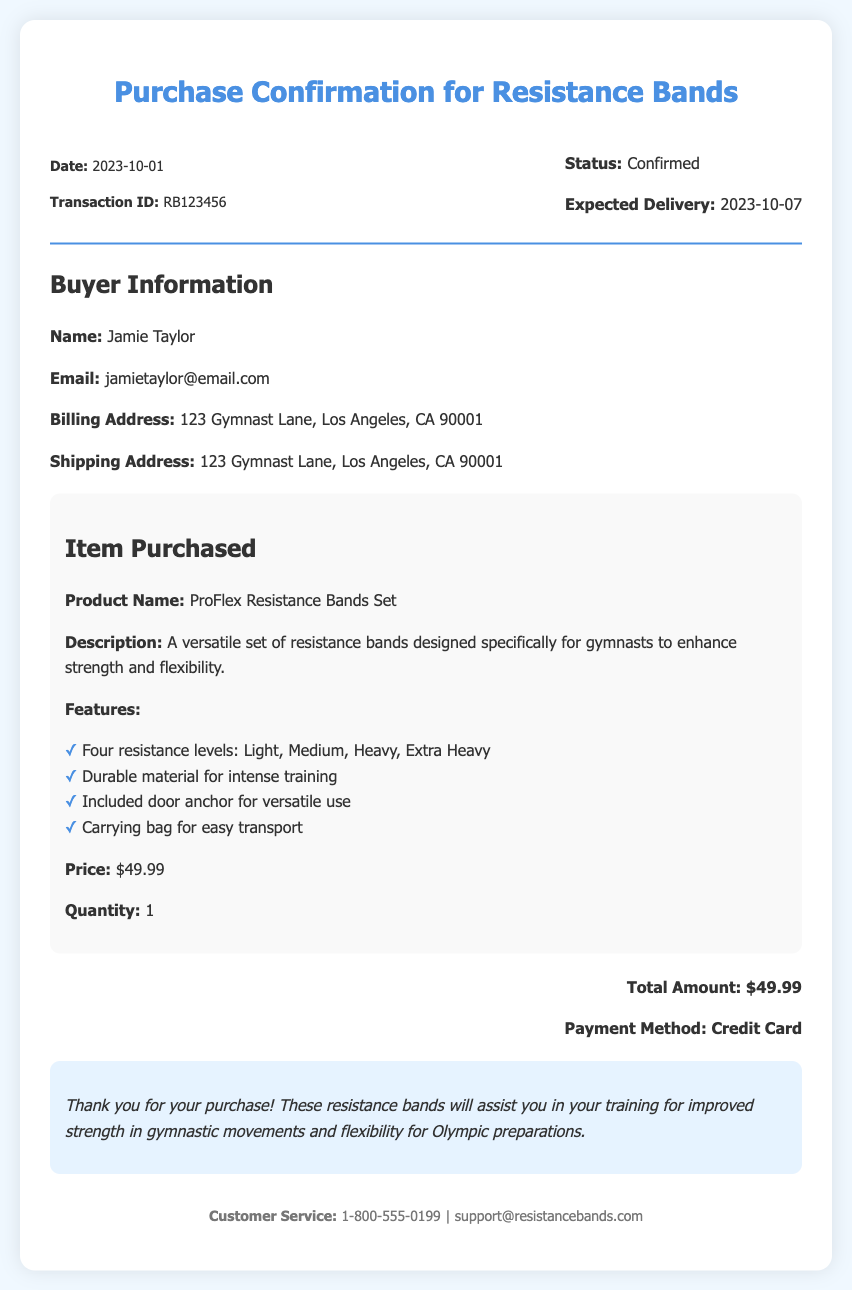What is the date of the purchase? The date of purchase is specified in the transaction details as the date the transaction occurred.
Answer: 2023-10-01 What is the transaction ID? The transaction ID is a unique identifier for this purchase, found in the transaction details section.
Answer: RB123456 What is the buyer's name? The buyer's name is mentioned in the buyer information section of the document.
Answer: Jamie Taylor What is the expected delivery date? The expected delivery date is stated in the order status section, indicating when the item will arrive.
Answer: 2023-10-07 How many resistance bands are included in the purchase? The quantity of the item purchased is listed in the item information section.
Answer: 1 What is the price of the ProFlex Resistance Bands Set? The price is specified under the item purchased section, detailing the cost of that specific item.
Answer: $49.99 What feature is included for versatile use? One of the features of the product is mentioned in the item information section, relating to how the item can be used.
Answer: Door anchor Why are these resistance bands beneficial for training? The document indicates a connection between the product and the user's training goals, providing a specific purpose.
Answer: Improve strength in gymnastic movements and flexibility What is the payment method used for the purchase? The payment method is found in the total information section, indicating how the purchase was paid for.
Answer: Credit Card 